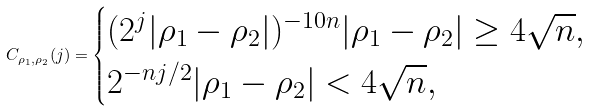<formula> <loc_0><loc_0><loc_500><loc_500>C _ { \rho _ { 1 } , \rho _ { 2 } } ( j ) = \begin{cases} ( 2 ^ { j } | \rho _ { 1 } - \rho _ { 2 } | ) ^ { - 1 0 n } | \rho _ { 1 } - \rho _ { 2 } | \geq 4 \sqrt { n } , \\ 2 ^ { - n j / 2 } | \rho _ { 1 } - \rho _ { 2 } | < 4 \sqrt { n } , \end{cases}</formula> 